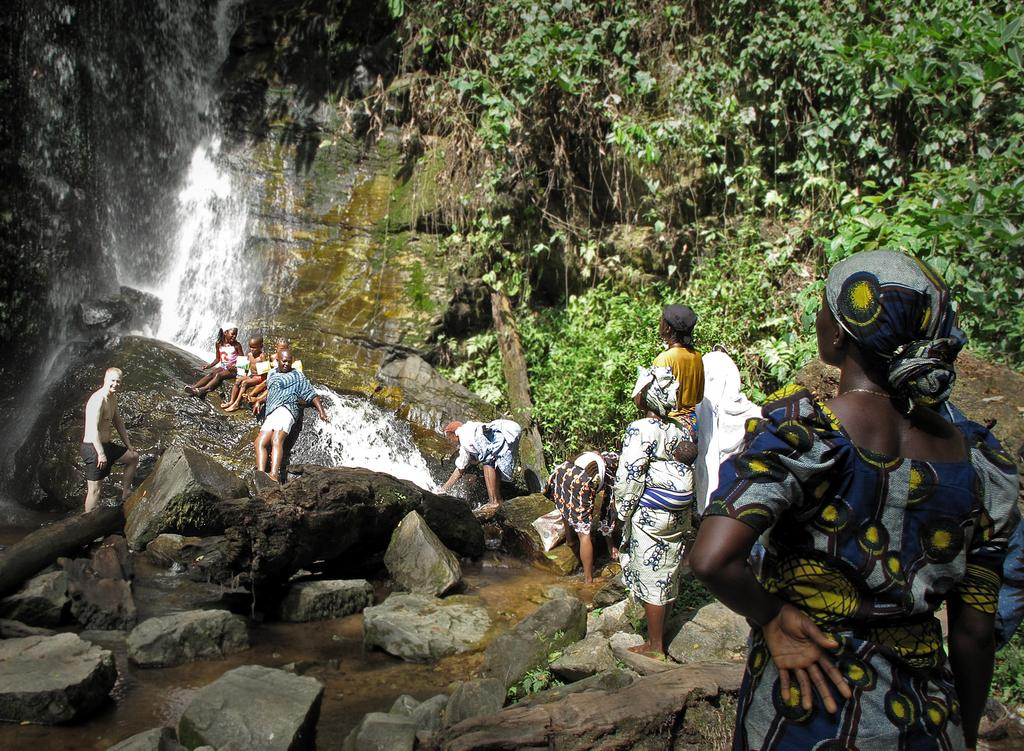What is the terrain like in the image? The terrain is rocky, as there are persons standing on a rocky surface. What other geological features can be seen in the image? There are huge rocks and a mountain in the image. Are there any natural water features in the image? Yes, there is a waterfall in the image. What type of vegetation is present in the image? There are green trees in the image. Can you see any snakes slithering among the rocks in the image? There is no snake present in the image. What type of payment is being made by the persons standing on the rocky surface? There is no payment being made in the image; it is a natural landscape scene. 